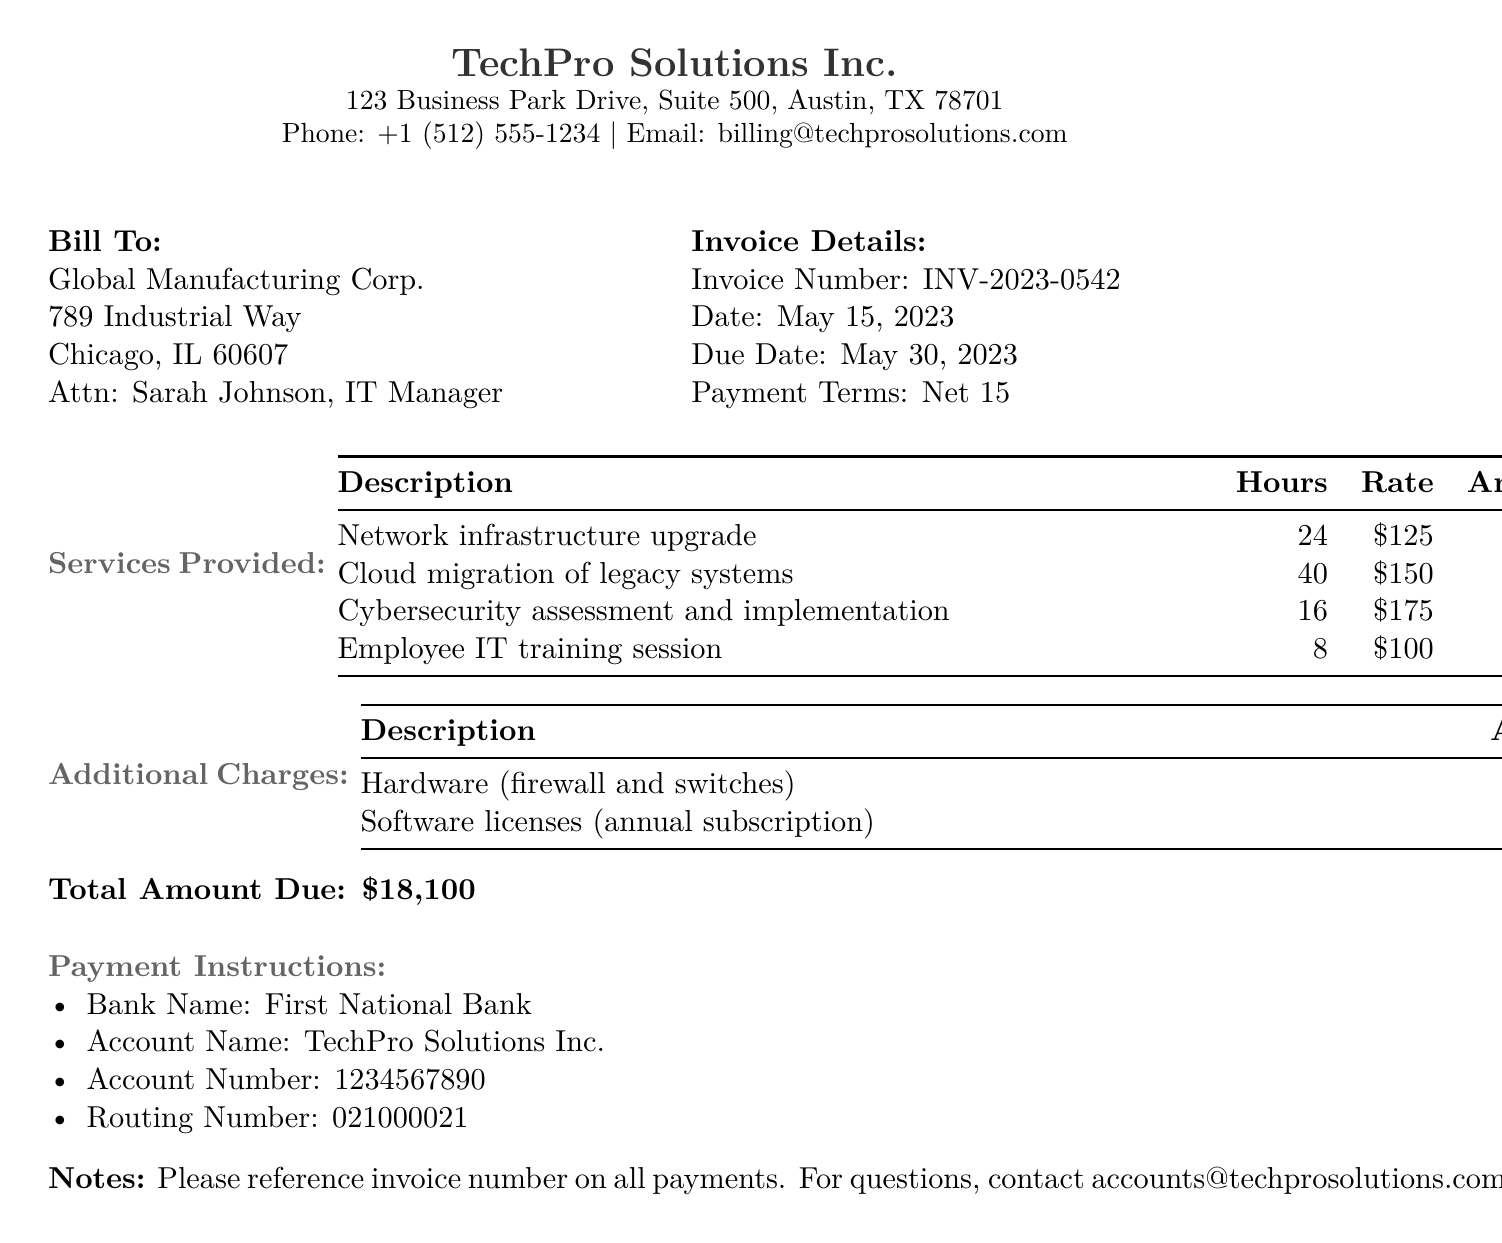What is the invoice number? The invoice number is listed in the invoice details section.
Answer: INV-2023-0542 Who is the IT Manager at Global Manufacturing Corp.? The IT Manager's name is provided under the billing information.
Answer: Sarah Johnson What is the due date of the invoice? The due date is stated in the invoice details section.
Answer: May 30, 2023 How much was charged for hardware? The amount charged for hardware is listed under additional charges.
Answer: $3,500 What is the total amount due? The total amount due summarizes all charges listed in the document.
Answer: $18,100 How many hours were spent on the cloud migration? The number of hours for each service is listed in the services provided table.
Answer: 40 What is the hourly rate for the cybersecurity assessment? The rate is indicated in the services provided table next to the task description.
Answer: $175 What is the payment term stated in the invoice? The payment term is specified in the invoice details section.
Answer: Net 15 How many services are detailed in the invoice? The number of services is obtained by counting the descriptions in the services provided section.
Answer: 4 